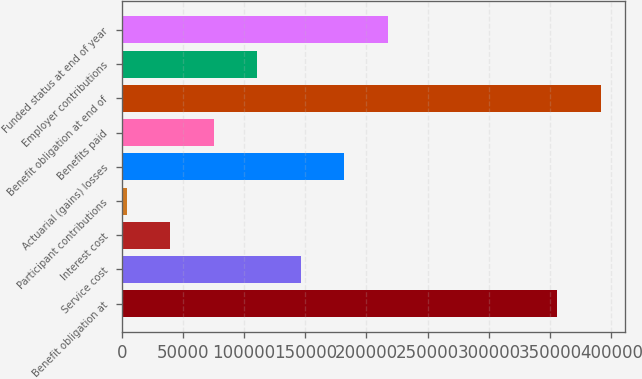Convert chart. <chart><loc_0><loc_0><loc_500><loc_500><bar_chart><fcel>Benefit obligation at<fcel>Service cost<fcel>Interest cost<fcel>Participant contributions<fcel>Actuarial (gains) losses<fcel>Benefits paid<fcel>Benefit obligation at end of<fcel>Employer contributions<fcel>Funded status at end of year<nl><fcel>355766<fcel>146147<fcel>39512.8<fcel>3968<fcel>181692<fcel>75057.6<fcel>391311<fcel>110602<fcel>217237<nl></chart> 